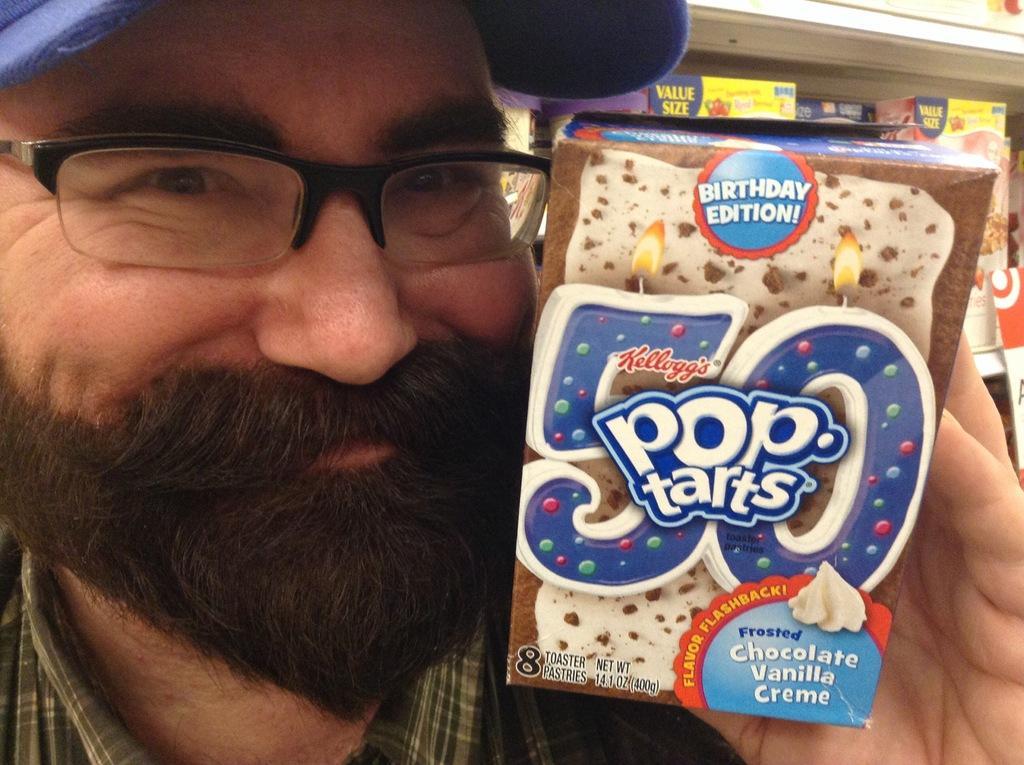In one or two sentences, can you explain what this image depicts? In this picture we can see a man, he wore spectacles and a cap, and he is holding a box, in the background we can find few more boxes in the racks. 